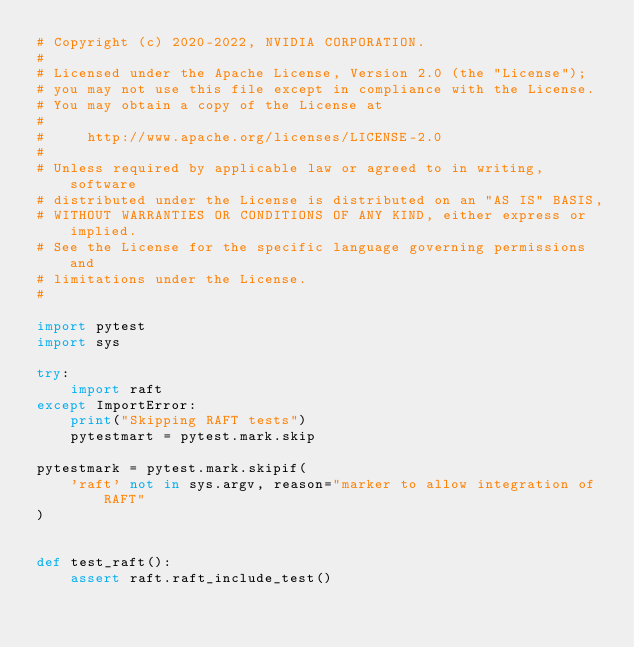Convert code to text. <code><loc_0><loc_0><loc_500><loc_500><_Python_># Copyright (c) 2020-2022, NVIDIA CORPORATION.
#
# Licensed under the Apache License, Version 2.0 (the "License");
# you may not use this file except in compliance with the License.
# You may obtain a copy of the License at
#
#     http://www.apache.org/licenses/LICENSE-2.0
#
# Unless required by applicable law or agreed to in writing, software
# distributed under the License is distributed on an "AS IS" BASIS,
# WITHOUT WARRANTIES OR CONDITIONS OF ANY KIND, either express or implied.
# See the License for the specific language governing permissions and
# limitations under the License.
#

import pytest
import sys

try:
    import raft
except ImportError:
    print("Skipping RAFT tests")
    pytestmart = pytest.mark.skip

pytestmark = pytest.mark.skipif(
    'raft' not in sys.argv, reason="marker to allow integration of RAFT"
)


def test_raft():
    assert raft.raft_include_test()
</code> 